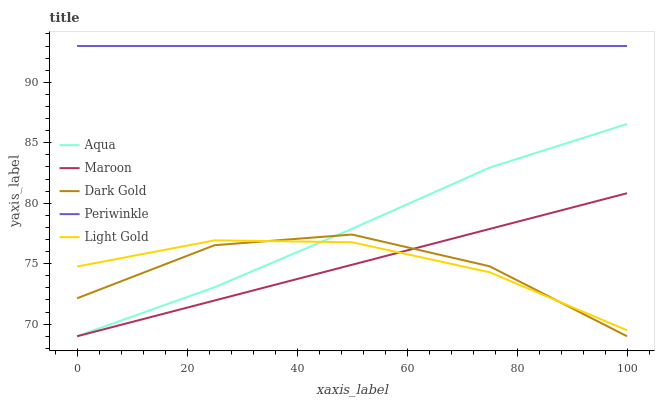Does Dark Gold have the minimum area under the curve?
Answer yes or no. Yes. Does Periwinkle have the maximum area under the curve?
Answer yes or no. Yes. Does Light Gold have the minimum area under the curve?
Answer yes or no. No. Does Light Gold have the maximum area under the curve?
Answer yes or no. No. Is Periwinkle the smoothest?
Answer yes or no. Yes. Is Dark Gold the roughest?
Answer yes or no. Yes. Is Light Gold the smoothest?
Answer yes or no. No. Is Light Gold the roughest?
Answer yes or no. No. Does Light Gold have the lowest value?
Answer yes or no. No. Does Periwinkle have the highest value?
Answer yes or no. Yes. Does Aqua have the highest value?
Answer yes or no. No. Is Light Gold less than Periwinkle?
Answer yes or no. Yes. Is Periwinkle greater than Dark Gold?
Answer yes or no. Yes. Does Dark Gold intersect Maroon?
Answer yes or no. Yes. Is Dark Gold less than Maroon?
Answer yes or no. No. Is Dark Gold greater than Maroon?
Answer yes or no. No. Does Light Gold intersect Periwinkle?
Answer yes or no. No. 